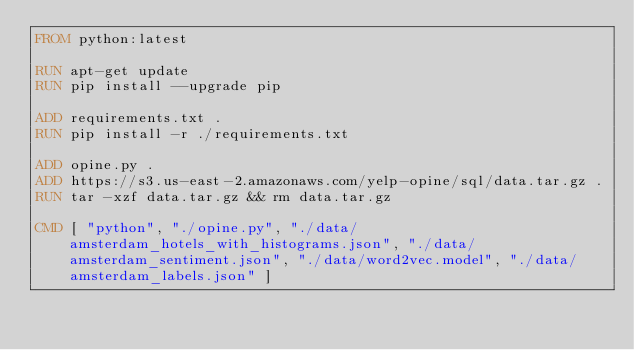<code> <loc_0><loc_0><loc_500><loc_500><_Dockerfile_>FROM python:latest

RUN apt-get update
RUN pip install --upgrade pip

ADD requirements.txt .
RUN pip install -r ./requirements.txt

ADD opine.py .
ADD https://s3.us-east-2.amazonaws.com/yelp-opine/sql/data.tar.gz .
RUN tar -xzf data.tar.gz && rm data.tar.gz

CMD [ "python", "./opine.py", "./data/amsterdam_hotels_with_histograms.json", "./data/amsterdam_sentiment.json", "./data/word2vec.model", "./data/amsterdam_labels.json" ]
</code> 